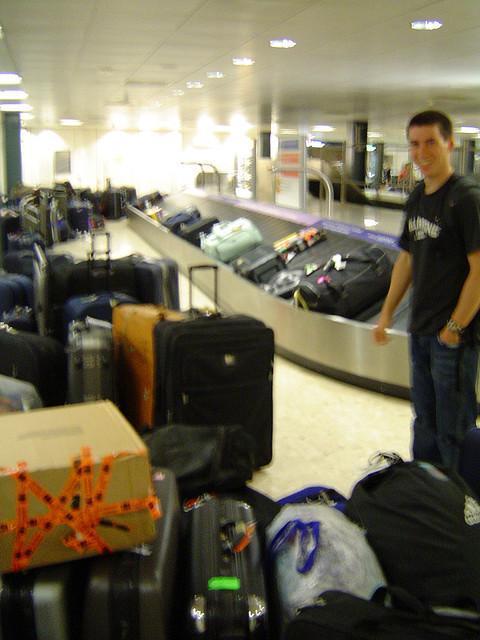How many cardboard boxes are there in this scene?
Give a very brief answer. 1. How many people are pictured?
Give a very brief answer. 1. How many suitcases are visible?
Give a very brief answer. 9. How many sheep are there?
Give a very brief answer. 0. 